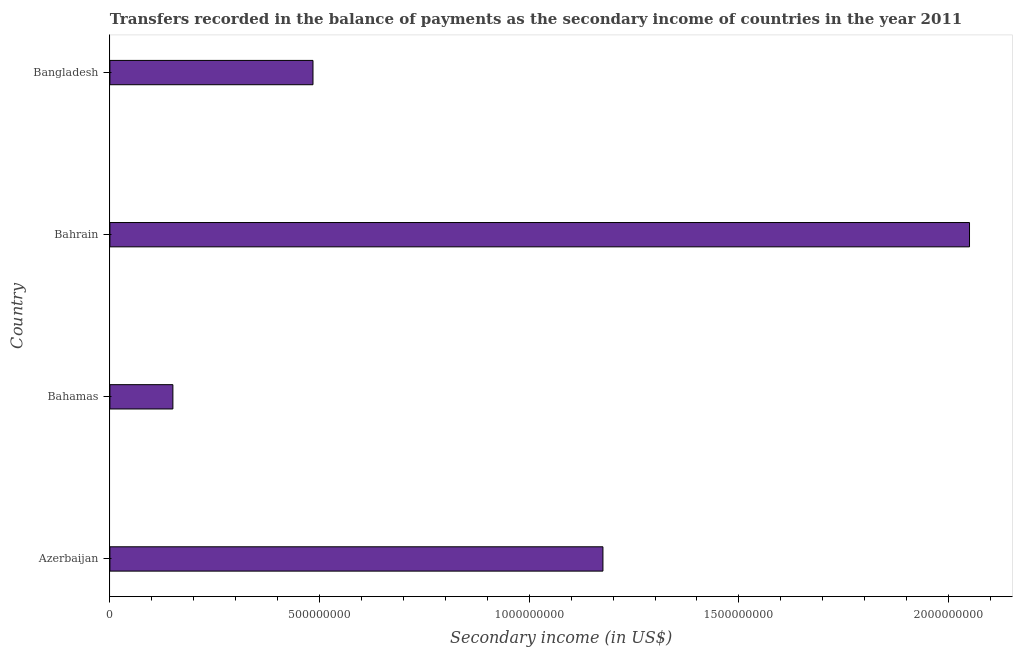Does the graph contain grids?
Provide a succinct answer. No. What is the title of the graph?
Offer a terse response. Transfers recorded in the balance of payments as the secondary income of countries in the year 2011. What is the label or title of the X-axis?
Provide a short and direct response. Secondary income (in US$). What is the label or title of the Y-axis?
Offer a very short reply. Country. What is the amount of secondary income in Bahamas?
Your answer should be compact. 1.50e+08. Across all countries, what is the maximum amount of secondary income?
Your answer should be very brief. 2.05e+09. Across all countries, what is the minimum amount of secondary income?
Offer a terse response. 1.50e+08. In which country was the amount of secondary income maximum?
Keep it short and to the point. Bahrain. In which country was the amount of secondary income minimum?
Your answer should be compact. Bahamas. What is the sum of the amount of secondary income?
Offer a very short reply. 3.86e+09. What is the difference between the amount of secondary income in Bahrain and Bangladesh?
Keep it short and to the point. 1.57e+09. What is the average amount of secondary income per country?
Make the answer very short. 9.65e+08. What is the median amount of secondary income?
Give a very brief answer. 8.30e+08. In how many countries, is the amount of secondary income greater than 1900000000 US$?
Your answer should be very brief. 1. What is the ratio of the amount of secondary income in Azerbaijan to that in Bahamas?
Keep it short and to the point. 7.83. What is the difference between the highest and the second highest amount of secondary income?
Offer a terse response. 8.74e+08. Is the sum of the amount of secondary income in Bahamas and Bahrain greater than the maximum amount of secondary income across all countries?
Provide a short and direct response. Yes. What is the difference between the highest and the lowest amount of secondary income?
Give a very brief answer. 1.90e+09. In how many countries, is the amount of secondary income greater than the average amount of secondary income taken over all countries?
Offer a very short reply. 2. How many countries are there in the graph?
Provide a short and direct response. 4. Are the values on the major ticks of X-axis written in scientific E-notation?
Ensure brevity in your answer.  No. What is the Secondary income (in US$) in Azerbaijan?
Ensure brevity in your answer.  1.18e+09. What is the Secondary income (in US$) of Bahamas?
Your answer should be compact. 1.50e+08. What is the Secondary income (in US$) of Bahrain?
Your answer should be very brief. 2.05e+09. What is the Secondary income (in US$) in Bangladesh?
Your response must be concise. 4.84e+08. What is the difference between the Secondary income (in US$) in Azerbaijan and Bahamas?
Offer a terse response. 1.03e+09. What is the difference between the Secondary income (in US$) in Azerbaijan and Bahrain?
Your response must be concise. -8.74e+08. What is the difference between the Secondary income (in US$) in Azerbaijan and Bangladesh?
Keep it short and to the point. 6.91e+08. What is the difference between the Secondary income (in US$) in Bahamas and Bahrain?
Offer a very short reply. -1.90e+09. What is the difference between the Secondary income (in US$) in Bahamas and Bangladesh?
Offer a very short reply. -3.34e+08. What is the difference between the Secondary income (in US$) in Bahrain and Bangladesh?
Give a very brief answer. 1.57e+09. What is the ratio of the Secondary income (in US$) in Azerbaijan to that in Bahamas?
Provide a short and direct response. 7.83. What is the ratio of the Secondary income (in US$) in Azerbaijan to that in Bahrain?
Your response must be concise. 0.57. What is the ratio of the Secondary income (in US$) in Azerbaijan to that in Bangladesh?
Your answer should be very brief. 2.43. What is the ratio of the Secondary income (in US$) in Bahamas to that in Bahrain?
Keep it short and to the point. 0.07. What is the ratio of the Secondary income (in US$) in Bahamas to that in Bangladesh?
Offer a terse response. 0.31. What is the ratio of the Secondary income (in US$) in Bahrain to that in Bangladesh?
Provide a succinct answer. 4.23. 